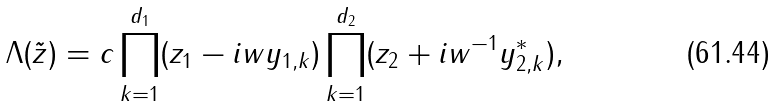Convert formula to latex. <formula><loc_0><loc_0><loc_500><loc_500>\Lambda ( \tilde { z } ) = c \prod _ { k = 1 } ^ { d _ { 1 } } ( z _ { 1 } - i w y _ { 1 , k } ) \prod _ { k = 1 } ^ { d _ { 2 } } ( z _ { 2 } + i w ^ { - 1 } y _ { 2 , k } ^ { * } ) ,</formula> 